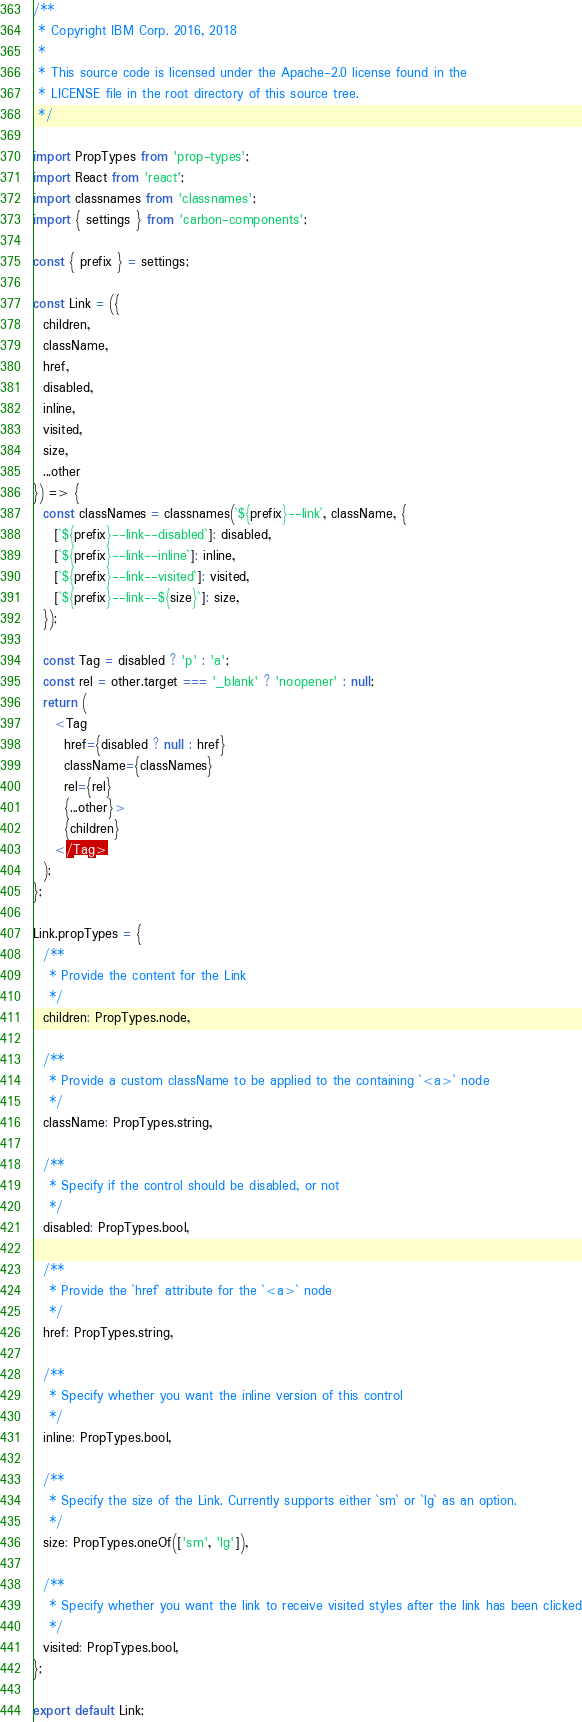Convert code to text. <code><loc_0><loc_0><loc_500><loc_500><_JavaScript_>/**
 * Copyright IBM Corp. 2016, 2018
 *
 * This source code is licensed under the Apache-2.0 license found in the
 * LICENSE file in the root directory of this source tree.
 */

import PropTypes from 'prop-types';
import React from 'react';
import classnames from 'classnames';
import { settings } from 'carbon-components';

const { prefix } = settings;

const Link = ({
  children,
  className,
  href,
  disabled,
  inline,
  visited,
  size,
  ...other
}) => {
  const classNames = classnames(`${prefix}--link`, className, {
    [`${prefix}--link--disabled`]: disabled,
    [`${prefix}--link--inline`]: inline,
    [`${prefix}--link--visited`]: visited,
    [`${prefix}--link--${size}`]: size,
  });

  const Tag = disabled ? 'p' : 'a';
  const rel = other.target === '_blank' ? 'noopener' : null;
  return (
    <Tag
      href={disabled ? null : href}
      className={classNames}
      rel={rel}
      {...other}>
      {children}
    </Tag>
  );
};

Link.propTypes = {
  /**
   * Provide the content for the Link
   */
  children: PropTypes.node,

  /**
   * Provide a custom className to be applied to the containing `<a>` node
   */
  className: PropTypes.string,

  /**
   * Specify if the control should be disabled, or not
   */
  disabled: PropTypes.bool,

  /**
   * Provide the `href` attribute for the `<a>` node
   */
  href: PropTypes.string,

  /**
   * Specify whether you want the inline version of this control
   */
  inline: PropTypes.bool,

  /**
   * Specify the size of the Link. Currently supports either `sm` or `lg` as an option.
   */
  size: PropTypes.oneOf(['sm', 'lg']),

  /**
   * Specify whether you want the link to receive visited styles after the link has been clicked
   */
  visited: PropTypes.bool,
};

export default Link;
</code> 